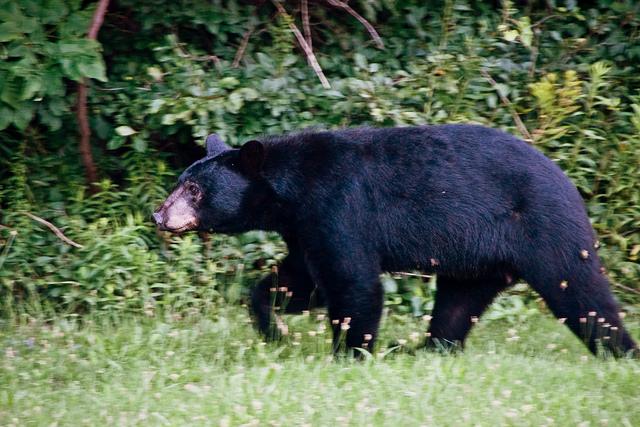What do you call these bears based on their age?
Keep it brief. Adult. Is this bear hunting?
Give a very brief answer. Yes. Is this a forest?
Short answer required. Yes. What kind and what color is the animal in the picture?
Answer briefly. Black bear. 